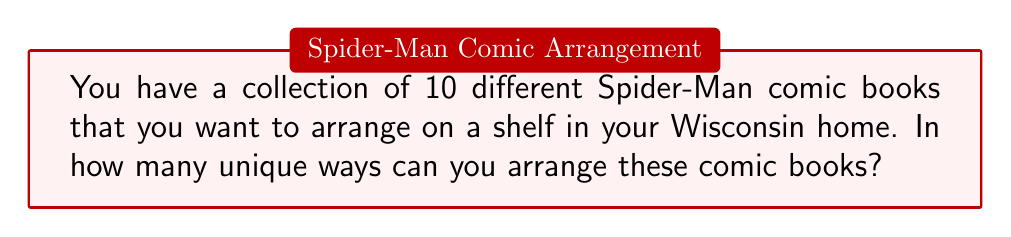Give your solution to this math problem. Let's approach this step-by-step:

1) This is a problem of permutation. We are arranging all 10 comic books, and the order matters.

2) In permutation problems where all items are distinct and all are being used, we use the formula:

   $$P(n) = n!$$

   Where $n$ is the number of distinct items.

3) In this case, $n = 10$ (10 different Spider-Man comic books).

4) So, we need to calculate:

   $$P(10) = 10!$$

5) Let's expand this:

   $$10! = 10 \times 9 \times 8 \times 7 \times 6 \times 5 \times 4 \times 3 \times 2 \times 1$$

6) Calculating this out:

   $$10! = 3,628,800$$

Therefore, there are 3,628,800 unique ways to arrange the 10 Spider-Man comic books on the shelf.
Answer: $3,628,800$ 